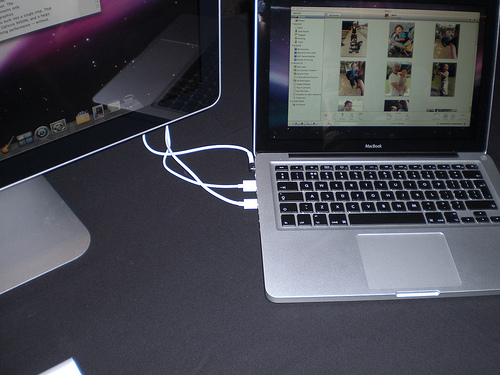<image>
Can you confirm if the desktop is to the right of the laptop? No. The desktop is not to the right of the laptop. The horizontal positioning shows a different relationship. 